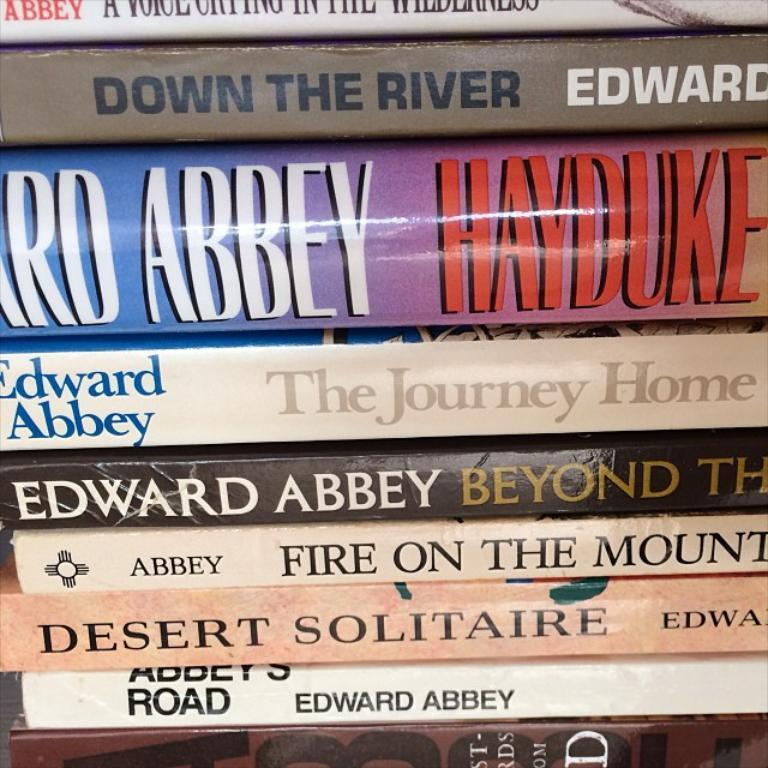<image>
Render a clear and concise summary of the photo. A stack of books including one titled Down the River. 